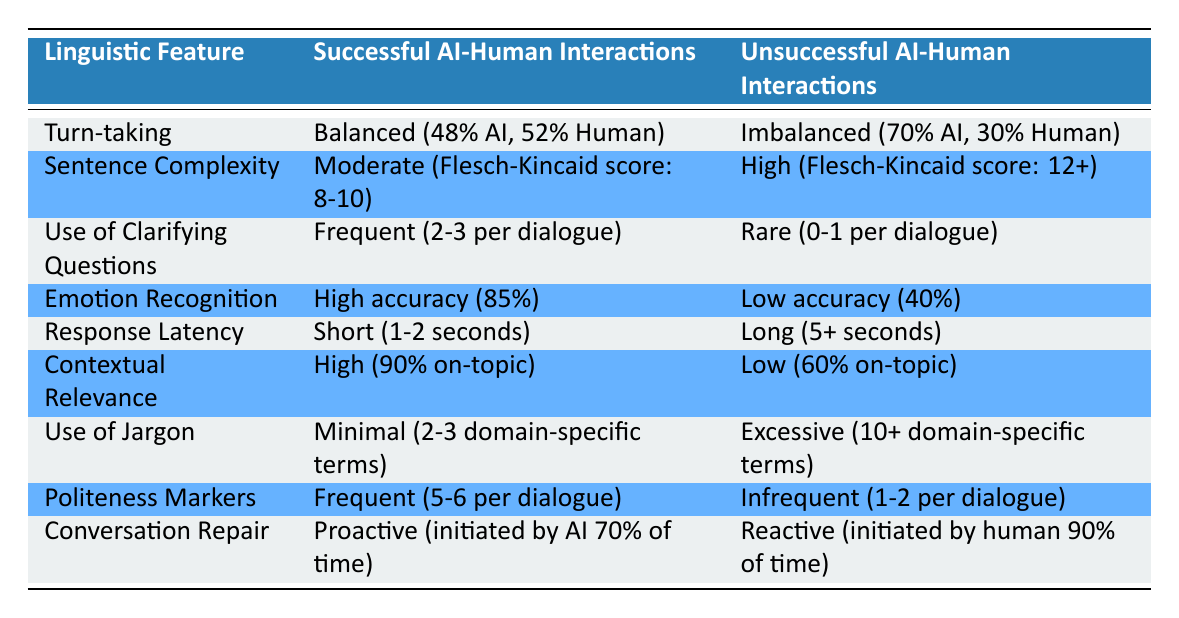What is the Flesch-Kincaid score for successful AI-human interactions? The table indicates that the Flesch-Kincaid score for successful AI-human interactions is moderate, specifically between 8 and 10.
Answer: 8-10 How often are clarifying questions used in unsuccessful AI-human interactions? According to the table, clarifying questions are used rarely in unsuccessful AI-human interactions, typically 0 to 1 per dialogue.
Answer: 0-1 Is the turn-taking in successful AI-human interactions more balanced than in unsuccessful ones? The table shows that successful interactions have a balanced turn-taking ratio (48% AI, 52% Human) compared to unsuccessful interactions which are imbalanced (70% AI, 30% Human). Therefore, the statement is true.
Answer: Yes What is the difference in accuracy for emotion recognition between successful and unsuccessful AI-human interactions? Successful interactions have an emotion recognition accuracy of 85%, while unsuccessful interactions have an accuracy of only 40%. To find the difference, subtract: 85% - 40% = 45%.
Answer: 45% What is the average contextual relevance score for both successful and unsuccessful AI-human interactions? The contextual relevance score for successful interactions is 90% on-topic, while for unsuccessful interactions, it is 60% on-topic. To find the average: (90% + 60%) / 2 = 75%.
Answer: 75% Do successful AI-human interactions typically exhibit a higher or lower use of jargon compared to unsuccessful interactions? The table indicates that successful interactions use minimal jargon (2-3 domain-specific terms) whereas unsuccessful interactions use excessive jargon (10+ domain-specific terms). Therefore, successful ones exhibit a lower use of jargon.
Answer: Lower In which type of interaction is the response latency shorter, successful or unsuccessful? The table states that successful interactions have a short response latency of 1-2 seconds, while unsuccessful interactions have a long response latency of 5+ seconds. This confirms that successful interactions have shorter response latency.
Answer: Successful How does the frequency of politeness markers differ between the two types of interactions? For successful interactions, politeness markers are frequent (5-6 per dialogue) compared to infrequent use (1-2 per dialogue) in unsuccessful interactions. This shows a clear difference in the frequency of politeness markers between the two types.
Answer: Frequent in successful, infrequent in unsuccessful 